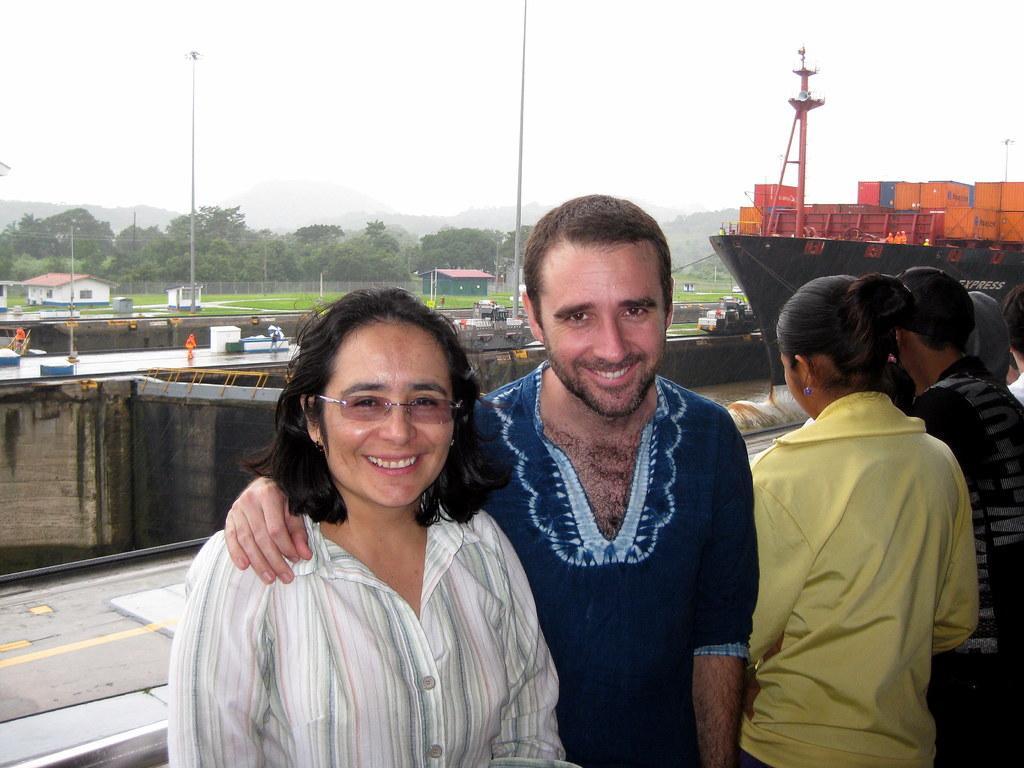Can you describe this image briefly? In this picture there is man wearing a blue color shirt, smiling and giving a pose. Beside there is a woman wearing white shirt is smiling and giving a pose into the camera. Behind there is a cargo ships and some fencing grill. In the background we can see many trees. 